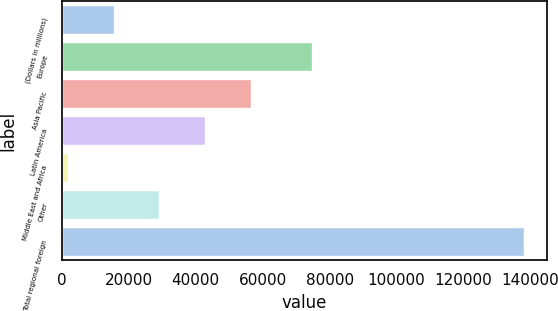Convert chart to OTSL. <chart><loc_0><loc_0><loc_500><loc_500><bar_chart><fcel>(Dollars in millions)<fcel>Europe<fcel>Asia Pacific<fcel>Latin America<fcel>Middle East and Africa<fcel>Other<fcel>Total regional foreign<nl><fcel>15562.1<fcel>74725<fcel>56395.4<fcel>42784.3<fcel>1951<fcel>29173.2<fcel>138062<nl></chart> 